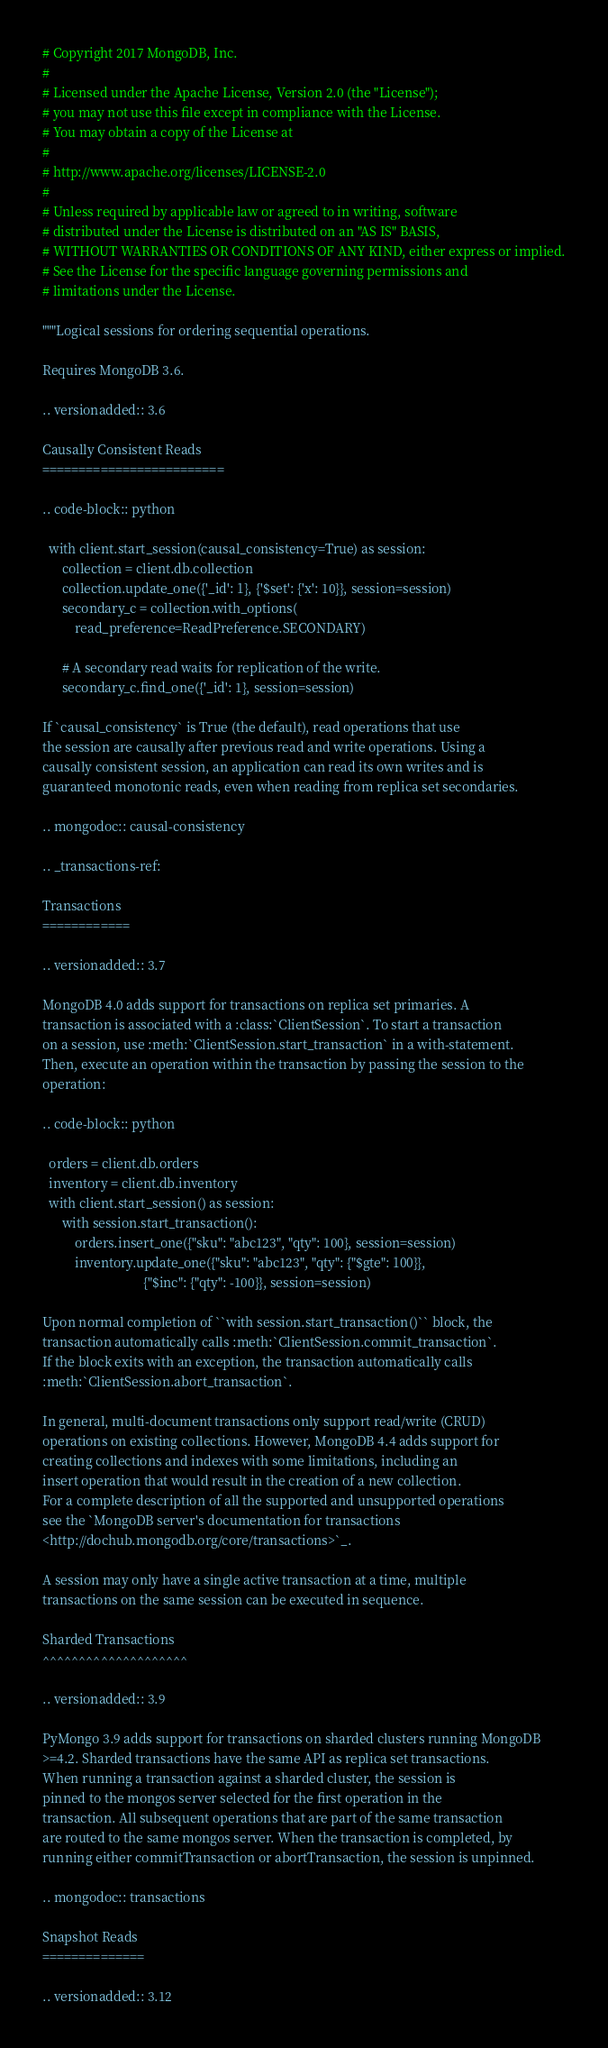<code> <loc_0><loc_0><loc_500><loc_500><_Python_># Copyright 2017 MongoDB, Inc.
#
# Licensed under the Apache License, Version 2.0 (the "License");
# you may not use this file except in compliance with the License.
# You may obtain a copy of the License at
#
# http://www.apache.org/licenses/LICENSE-2.0
#
# Unless required by applicable law or agreed to in writing, software
# distributed under the License is distributed on an "AS IS" BASIS,
# WITHOUT WARRANTIES OR CONDITIONS OF ANY KIND, either express or implied.
# See the License for the specific language governing permissions and
# limitations under the License.

"""Logical sessions for ordering sequential operations.

Requires MongoDB 3.6.

.. versionadded:: 3.6

Causally Consistent Reads
=========================

.. code-block:: python

  with client.start_session(causal_consistency=True) as session:
      collection = client.db.collection
      collection.update_one({'_id': 1}, {'$set': {'x': 10}}, session=session)
      secondary_c = collection.with_options(
          read_preference=ReadPreference.SECONDARY)

      # A secondary read waits for replication of the write.
      secondary_c.find_one({'_id': 1}, session=session)

If `causal_consistency` is True (the default), read operations that use
the session are causally after previous read and write operations. Using a
causally consistent session, an application can read its own writes and is
guaranteed monotonic reads, even when reading from replica set secondaries.

.. mongodoc:: causal-consistency

.. _transactions-ref:

Transactions
============

.. versionadded:: 3.7

MongoDB 4.0 adds support for transactions on replica set primaries. A
transaction is associated with a :class:`ClientSession`. To start a transaction
on a session, use :meth:`ClientSession.start_transaction` in a with-statement.
Then, execute an operation within the transaction by passing the session to the
operation:

.. code-block:: python

  orders = client.db.orders
  inventory = client.db.inventory
  with client.start_session() as session:
      with session.start_transaction():
          orders.insert_one({"sku": "abc123", "qty": 100}, session=session)
          inventory.update_one({"sku": "abc123", "qty": {"$gte": 100}},
                               {"$inc": {"qty": -100}}, session=session)

Upon normal completion of ``with session.start_transaction()`` block, the
transaction automatically calls :meth:`ClientSession.commit_transaction`.
If the block exits with an exception, the transaction automatically calls
:meth:`ClientSession.abort_transaction`.

In general, multi-document transactions only support read/write (CRUD)
operations on existing collections. However, MongoDB 4.4 adds support for
creating collections and indexes with some limitations, including an
insert operation that would result in the creation of a new collection.
For a complete description of all the supported and unsupported operations
see the `MongoDB server's documentation for transactions
<http://dochub.mongodb.org/core/transactions>`_.

A session may only have a single active transaction at a time, multiple
transactions on the same session can be executed in sequence.

Sharded Transactions
^^^^^^^^^^^^^^^^^^^^

.. versionadded:: 3.9

PyMongo 3.9 adds support for transactions on sharded clusters running MongoDB
>=4.2. Sharded transactions have the same API as replica set transactions.
When running a transaction against a sharded cluster, the session is
pinned to the mongos server selected for the first operation in the
transaction. All subsequent operations that are part of the same transaction
are routed to the same mongos server. When the transaction is completed, by
running either commitTransaction or abortTransaction, the session is unpinned.

.. mongodoc:: transactions

Snapshot Reads
==============

.. versionadded:: 3.12
</code> 